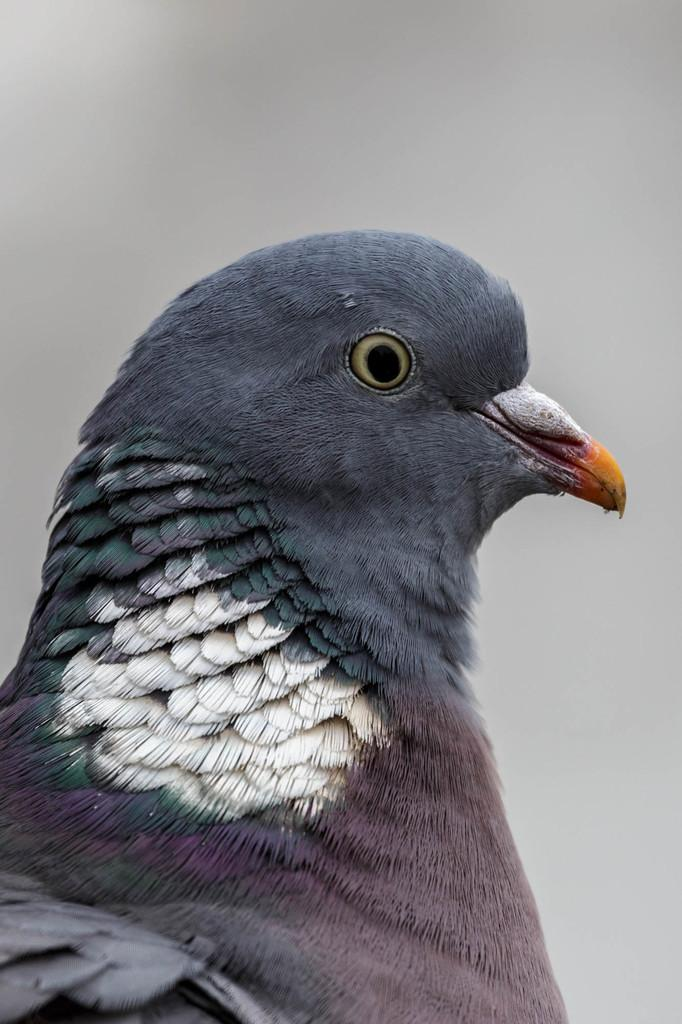What type of bird is in the image? There is a pigeon in the image. Where is the pigeon located in the image? The pigeon is in the front of the image. Can you describe the background of the image? The background of the image is blurry. How many rings does the pigeon have on its fang in the image? There are no rings or fangs present on the pigeon in the image. 